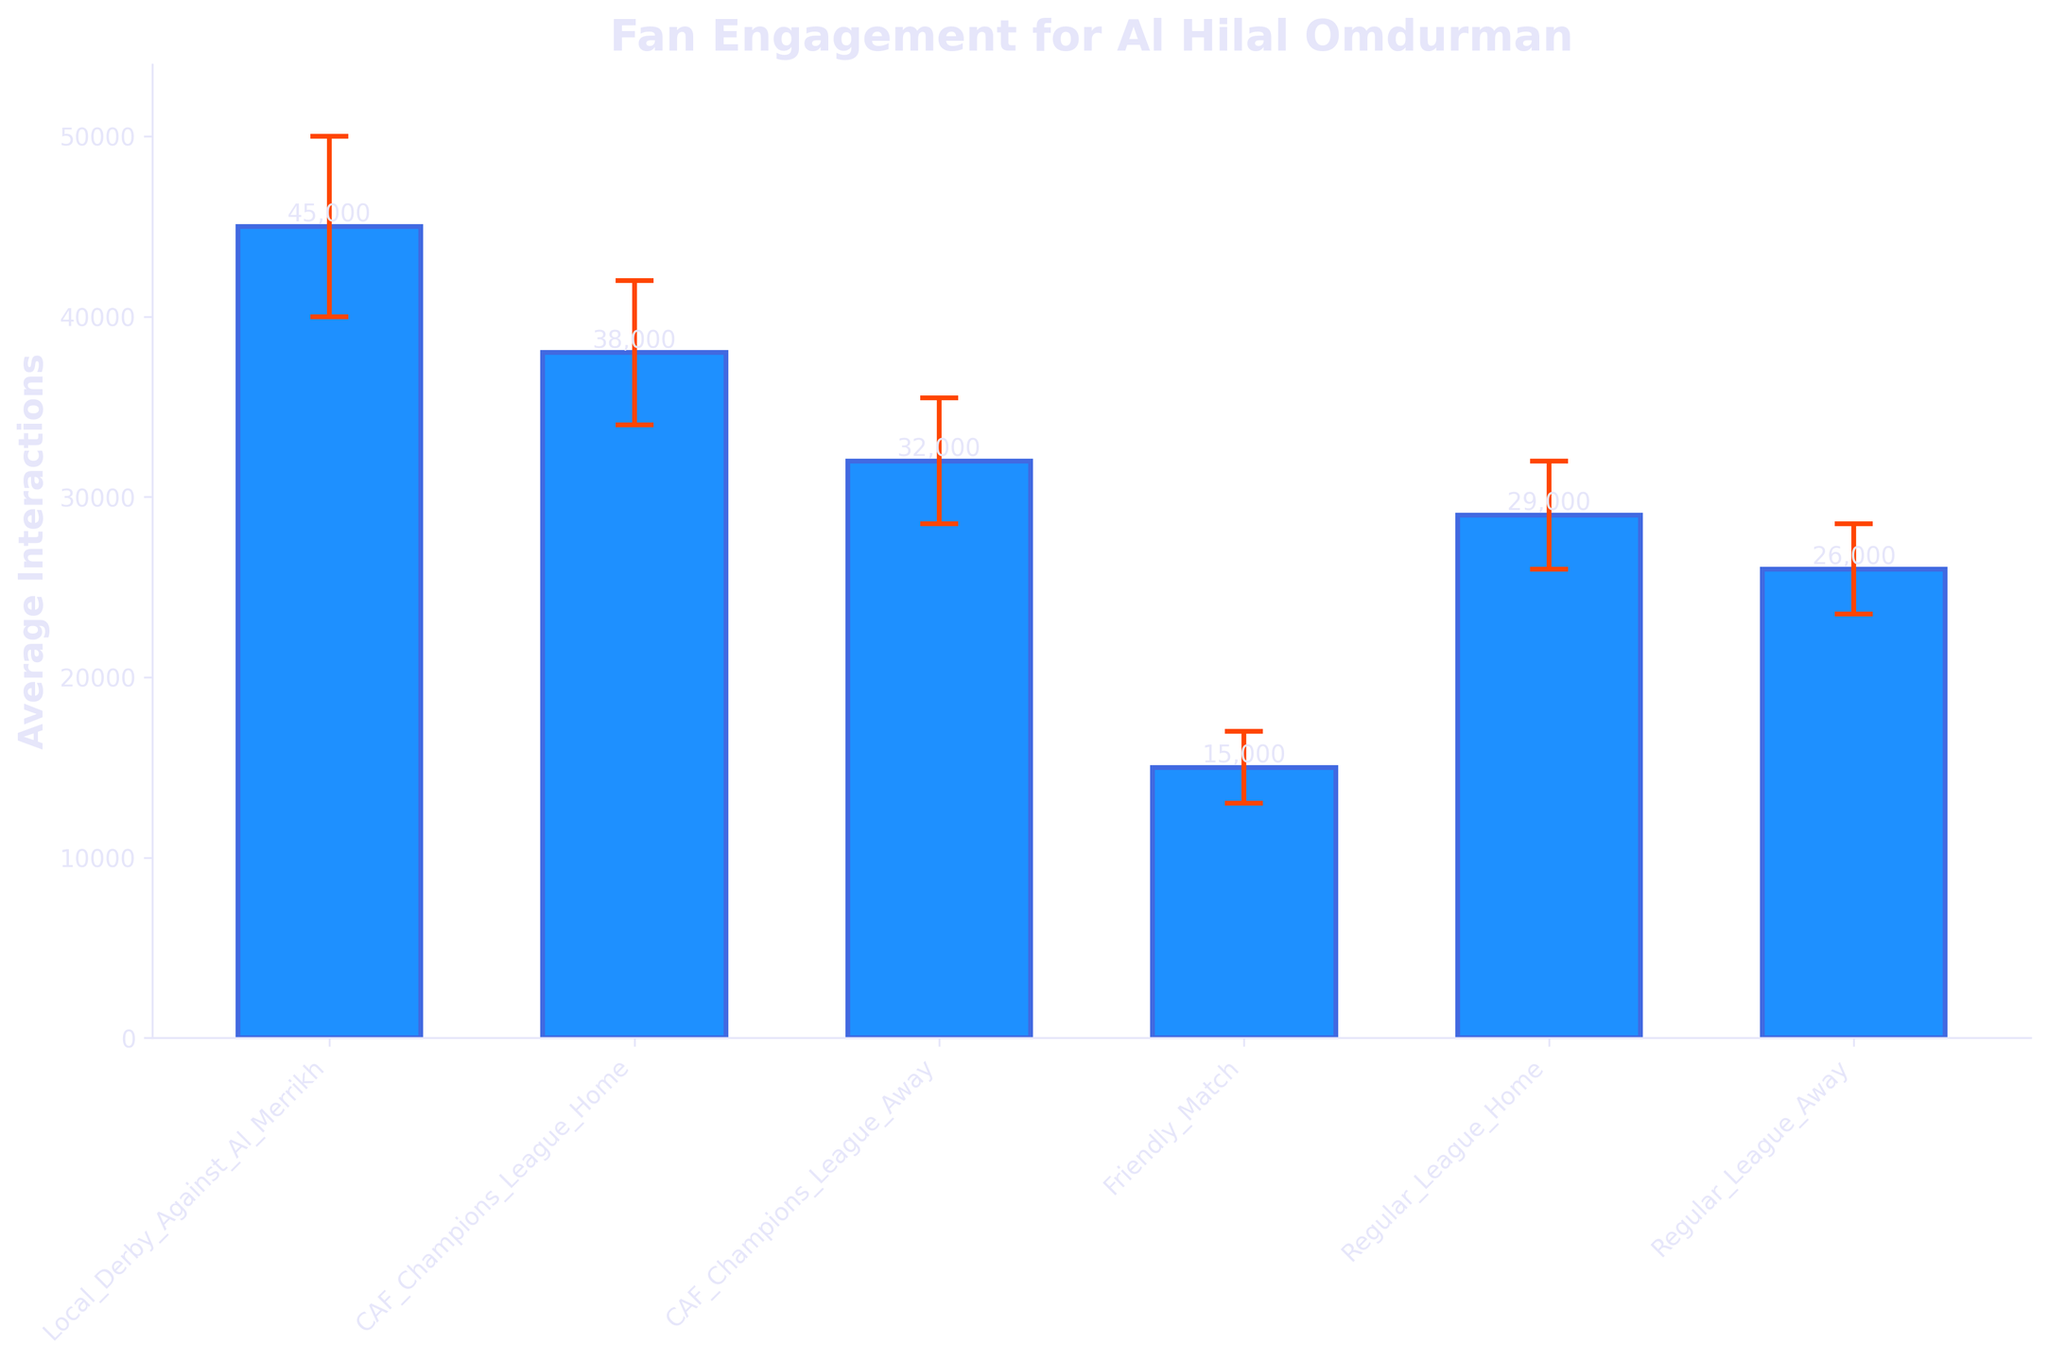what is the title of the figure? The title of a figure is usually located at the top and summarizes the overall topic of the chart. In this figure, the title is clearly displayed.
Answer: Fan Engagement for Al Hilal Omdurman how many match days are displayed in the figure? By counting the number of bars or the labels on the x-axis, we can determine the number of match days.
Answer: 6 which match day has the highest average interactions? By comparing the height of each bar, the tallest bar corresponds to the highest average interactions.
Answer: Local Derby Against Al Merrikh what is the average interaction for friendly matches? Look at the height of the bar labeled "Friendly Match" to find its average interaction value.
Answer: 15,000 what is the average interaction difference between the local derby against Al Merrikh and the CAF Champions League home match? Subtract the average interactions for the CAF Champions League home match from the local derby against Al Merrikh. 45,000 - 38,000 = 7,000
Answer: 7,000 which match day shows the smallest error margin? By looking at the size of the error bars, the smallest error bar identifies the smallest error margin.
Answer: Friendly Match compare the average interactions of regular league home and away matches. which is higher? By comparing the heights of the bars for "Regular League Home" and "Regular League Away," the taller bar indicates the higher average interaction.
Answer: Regular League Home what is the overall range of average interactions shown in the figure? Find the difference between the highest and lowest average interactions. 45,000 (highest) - 15,000 (lowest) = 30,000
Answer: 30,000 what is the approximate error bar value for the CAF Champions League away match? The error bar for the CAF Champions League away match is represented by the top ends of the error caps. Referring to the figure, the error margin for this match is specified.
Answer: 3,500 which match day has the second highest average interactions? By identifying the second tallest bar, the match day corresponding to this bar has the second highest average interactions.
Answer: CAF Champions League Home 